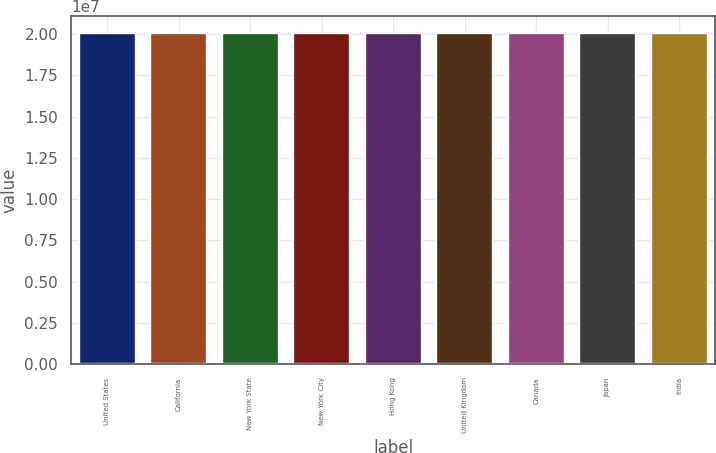<chart> <loc_0><loc_0><loc_500><loc_500><bar_chart><fcel>United States<fcel>California<fcel>New York State<fcel>New York City<fcel>Hong Kong<fcel>United Kingdom<fcel>Canada<fcel>Japan<fcel>India<nl><fcel>2.0052e+07<fcel>2.0092e+07<fcel>2.0072e+07<fcel>2.0077e+07<fcel>2.0062e+07<fcel>2.0102e+07<fcel>2.0067e+07<fcel>2.0097e+07<fcel>2.0082e+07<nl></chart> 